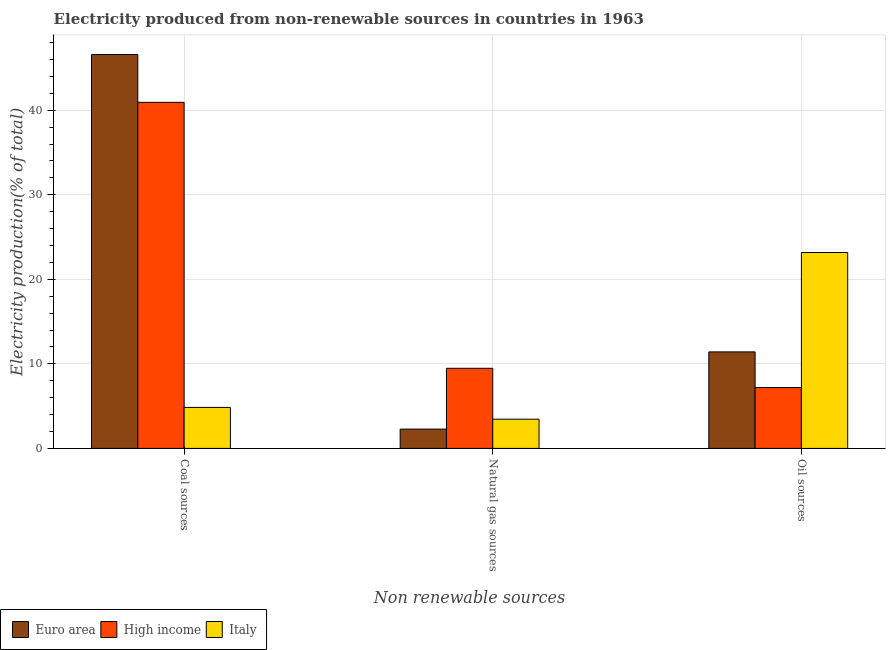How many different coloured bars are there?
Provide a short and direct response. 3. How many bars are there on the 2nd tick from the left?
Keep it short and to the point. 3. What is the label of the 1st group of bars from the left?
Provide a short and direct response. Coal sources. What is the percentage of electricity produced by natural gas in Italy?
Your answer should be very brief. 3.46. Across all countries, what is the maximum percentage of electricity produced by coal?
Your response must be concise. 46.59. Across all countries, what is the minimum percentage of electricity produced by natural gas?
Give a very brief answer. 2.28. What is the total percentage of electricity produced by oil sources in the graph?
Provide a succinct answer. 41.79. What is the difference between the percentage of electricity produced by coal in Euro area and that in High income?
Provide a short and direct response. 5.65. What is the difference between the percentage of electricity produced by natural gas in High income and the percentage of electricity produced by coal in Euro area?
Ensure brevity in your answer.  -37.11. What is the average percentage of electricity produced by natural gas per country?
Make the answer very short. 5.07. What is the difference between the percentage of electricity produced by natural gas and percentage of electricity produced by coal in Italy?
Provide a short and direct response. -1.4. What is the ratio of the percentage of electricity produced by oil sources in High income to that in Euro area?
Keep it short and to the point. 0.63. Is the percentage of electricity produced by coal in Italy less than that in Euro area?
Give a very brief answer. Yes. Is the difference between the percentage of electricity produced by natural gas in High income and Euro area greater than the difference between the percentage of electricity produced by coal in High income and Euro area?
Make the answer very short. Yes. What is the difference between the highest and the second highest percentage of electricity produced by natural gas?
Provide a short and direct response. 6.02. What is the difference between the highest and the lowest percentage of electricity produced by natural gas?
Ensure brevity in your answer.  7.19. In how many countries, is the percentage of electricity produced by oil sources greater than the average percentage of electricity produced by oil sources taken over all countries?
Keep it short and to the point. 1. Is the sum of the percentage of electricity produced by coal in Euro area and Italy greater than the maximum percentage of electricity produced by oil sources across all countries?
Provide a short and direct response. Yes. What does the 3rd bar from the left in Natural gas sources represents?
Make the answer very short. Italy. What does the 1st bar from the right in Natural gas sources represents?
Your response must be concise. Italy. How many countries are there in the graph?
Keep it short and to the point. 3. Does the graph contain any zero values?
Your response must be concise. No. Does the graph contain grids?
Your answer should be very brief. Yes. Where does the legend appear in the graph?
Offer a very short reply. Bottom left. What is the title of the graph?
Your response must be concise. Electricity produced from non-renewable sources in countries in 1963. What is the label or title of the X-axis?
Keep it short and to the point. Non renewable sources. What is the Electricity production(% of total) of Euro area in Coal sources?
Provide a short and direct response. 46.59. What is the Electricity production(% of total) in High income in Coal sources?
Provide a succinct answer. 40.94. What is the Electricity production(% of total) of Italy in Coal sources?
Provide a succinct answer. 4.85. What is the Electricity production(% of total) in Euro area in Natural gas sources?
Give a very brief answer. 2.28. What is the Electricity production(% of total) of High income in Natural gas sources?
Offer a terse response. 9.48. What is the Electricity production(% of total) in Italy in Natural gas sources?
Your answer should be very brief. 3.46. What is the Electricity production(% of total) in Euro area in Oil sources?
Offer a very short reply. 11.42. What is the Electricity production(% of total) of High income in Oil sources?
Your response must be concise. 7.2. What is the Electricity production(% of total) in Italy in Oil sources?
Give a very brief answer. 23.17. Across all Non renewable sources, what is the maximum Electricity production(% of total) in Euro area?
Make the answer very short. 46.59. Across all Non renewable sources, what is the maximum Electricity production(% of total) in High income?
Ensure brevity in your answer.  40.94. Across all Non renewable sources, what is the maximum Electricity production(% of total) of Italy?
Provide a succinct answer. 23.17. Across all Non renewable sources, what is the minimum Electricity production(% of total) of Euro area?
Provide a short and direct response. 2.28. Across all Non renewable sources, what is the minimum Electricity production(% of total) in High income?
Keep it short and to the point. 7.2. Across all Non renewable sources, what is the minimum Electricity production(% of total) of Italy?
Give a very brief answer. 3.46. What is the total Electricity production(% of total) in Euro area in the graph?
Your response must be concise. 60.29. What is the total Electricity production(% of total) of High income in the graph?
Provide a succinct answer. 57.62. What is the total Electricity production(% of total) of Italy in the graph?
Your answer should be very brief. 31.48. What is the difference between the Electricity production(% of total) in Euro area in Coal sources and that in Natural gas sources?
Keep it short and to the point. 44.31. What is the difference between the Electricity production(% of total) of High income in Coal sources and that in Natural gas sources?
Offer a very short reply. 31.46. What is the difference between the Electricity production(% of total) of Italy in Coal sources and that in Natural gas sources?
Provide a succinct answer. 1.4. What is the difference between the Electricity production(% of total) of Euro area in Coal sources and that in Oil sources?
Provide a succinct answer. 35.17. What is the difference between the Electricity production(% of total) of High income in Coal sources and that in Oil sources?
Keep it short and to the point. 33.74. What is the difference between the Electricity production(% of total) in Italy in Coal sources and that in Oil sources?
Your answer should be compact. -18.32. What is the difference between the Electricity production(% of total) of Euro area in Natural gas sources and that in Oil sources?
Give a very brief answer. -9.13. What is the difference between the Electricity production(% of total) of High income in Natural gas sources and that in Oil sources?
Your answer should be very brief. 2.28. What is the difference between the Electricity production(% of total) in Italy in Natural gas sources and that in Oil sources?
Your answer should be compact. -19.72. What is the difference between the Electricity production(% of total) in Euro area in Coal sources and the Electricity production(% of total) in High income in Natural gas sources?
Provide a succinct answer. 37.11. What is the difference between the Electricity production(% of total) of Euro area in Coal sources and the Electricity production(% of total) of Italy in Natural gas sources?
Provide a short and direct response. 43.13. What is the difference between the Electricity production(% of total) of High income in Coal sources and the Electricity production(% of total) of Italy in Natural gas sources?
Your response must be concise. 37.48. What is the difference between the Electricity production(% of total) of Euro area in Coal sources and the Electricity production(% of total) of High income in Oil sources?
Keep it short and to the point. 39.39. What is the difference between the Electricity production(% of total) of Euro area in Coal sources and the Electricity production(% of total) of Italy in Oil sources?
Provide a short and direct response. 23.41. What is the difference between the Electricity production(% of total) of High income in Coal sources and the Electricity production(% of total) of Italy in Oil sources?
Make the answer very short. 17.76. What is the difference between the Electricity production(% of total) in Euro area in Natural gas sources and the Electricity production(% of total) in High income in Oil sources?
Make the answer very short. -4.92. What is the difference between the Electricity production(% of total) of Euro area in Natural gas sources and the Electricity production(% of total) of Italy in Oil sources?
Keep it short and to the point. -20.89. What is the difference between the Electricity production(% of total) in High income in Natural gas sources and the Electricity production(% of total) in Italy in Oil sources?
Give a very brief answer. -13.7. What is the average Electricity production(% of total) of Euro area per Non renewable sources?
Your answer should be very brief. 20.1. What is the average Electricity production(% of total) in High income per Non renewable sources?
Provide a succinct answer. 19.21. What is the average Electricity production(% of total) of Italy per Non renewable sources?
Your answer should be very brief. 10.49. What is the difference between the Electricity production(% of total) of Euro area and Electricity production(% of total) of High income in Coal sources?
Your answer should be compact. 5.65. What is the difference between the Electricity production(% of total) of Euro area and Electricity production(% of total) of Italy in Coal sources?
Offer a terse response. 41.74. What is the difference between the Electricity production(% of total) in High income and Electricity production(% of total) in Italy in Coal sources?
Offer a very short reply. 36.09. What is the difference between the Electricity production(% of total) in Euro area and Electricity production(% of total) in High income in Natural gas sources?
Your answer should be compact. -7.19. What is the difference between the Electricity production(% of total) in Euro area and Electricity production(% of total) in Italy in Natural gas sources?
Your response must be concise. -1.17. What is the difference between the Electricity production(% of total) of High income and Electricity production(% of total) of Italy in Natural gas sources?
Make the answer very short. 6.02. What is the difference between the Electricity production(% of total) in Euro area and Electricity production(% of total) in High income in Oil sources?
Make the answer very short. 4.22. What is the difference between the Electricity production(% of total) in Euro area and Electricity production(% of total) in Italy in Oil sources?
Make the answer very short. -11.76. What is the difference between the Electricity production(% of total) in High income and Electricity production(% of total) in Italy in Oil sources?
Make the answer very short. -15.97. What is the ratio of the Electricity production(% of total) of Euro area in Coal sources to that in Natural gas sources?
Keep it short and to the point. 20.4. What is the ratio of the Electricity production(% of total) in High income in Coal sources to that in Natural gas sources?
Make the answer very short. 4.32. What is the ratio of the Electricity production(% of total) in Italy in Coal sources to that in Natural gas sources?
Give a very brief answer. 1.4. What is the ratio of the Electricity production(% of total) in Euro area in Coal sources to that in Oil sources?
Offer a very short reply. 4.08. What is the ratio of the Electricity production(% of total) in High income in Coal sources to that in Oil sources?
Provide a succinct answer. 5.69. What is the ratio of the Electricity production(% of total) in Italy in Coal sources to that in Oil sources?
Give a very brief answer. 0.21. What is the ratio of the Electricity production(% of total) in Euro area in Natural gas sources to that in Oil sources?
Keep it short and to the point. 0.2. What is the ratio of the Electricity production(% of total) in High income in Natural gas sources to that in Oil sources?
Your answer should be compact. 1.32. What is the ratio of the Electricity production(% of total) in Italy in Natural gas sources to that in Oil sources?
Your answer should be compact. 0.15. What is the difference between the highest and the second highest Electricity production(% of total) of Euro area?
Offer a terse response. 35.17. What is the difference between the highest and the second highest Electricity production(% of total) of High income?
Offer a very short reply. 31.46. What is the difference between the highest and the second highest Electricity production(% of total) in Italy?
Offer a very short reply. 18.32. What is the difference between the highest and the lowest Electricity production(% of total) of Euro area?
Offer a terse response. 44.31. What is the difference between the highest and the lowest Electricity production(% of total) in High income?
Ensure brevity in your answer.  33.74. What is the difference between the highest and the lowest Electricity production(% of total) of Italy?
Make the answer very short. 19.72. 